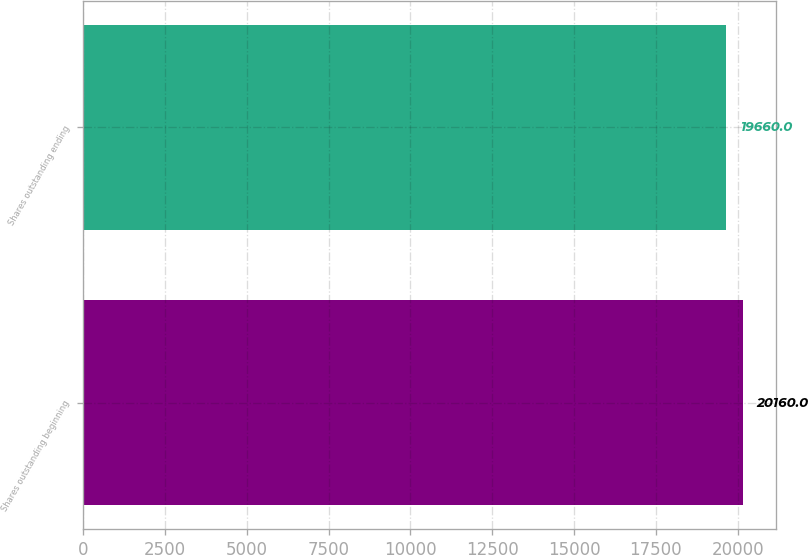Convert chart to OTSL. <chart><loc_0><loc_0><loc_500><loc_500><bar_chart><fcel>Shares outstanding beginning<fcel>Shares outstanding ending<nl><fcel>20160<fcel>19660<nl></chart> 